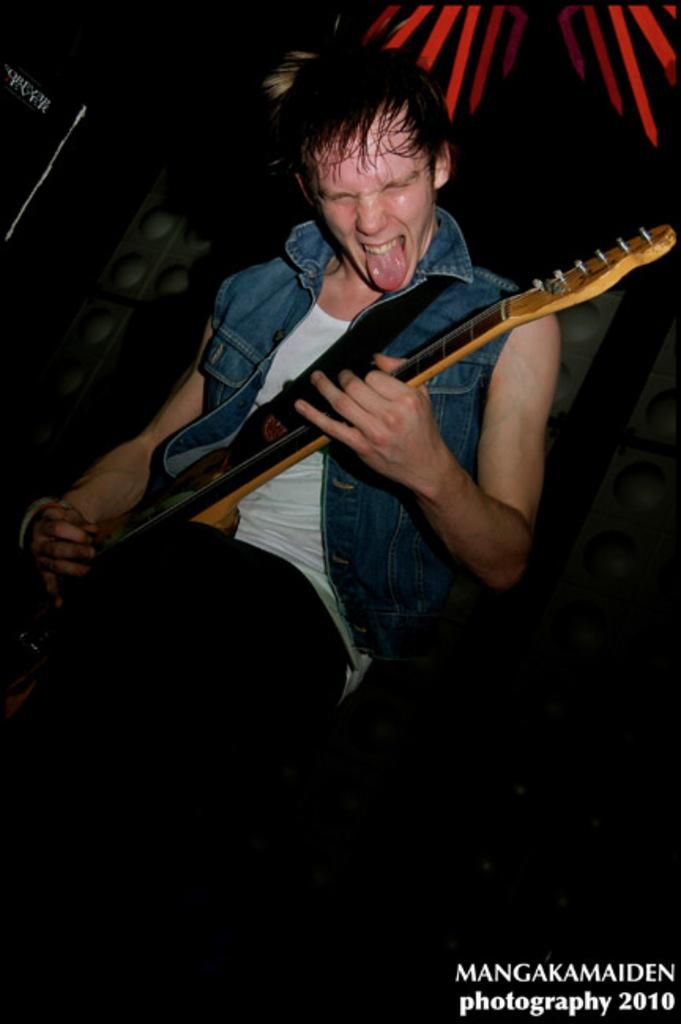What is the main subject of the image? There is a man in the image. What is the man doing in the image? The man is playing a guitar. What type of underwear is the man wearing in the image? There is no information about the man's underwear in the image, so it cannot be determined. 